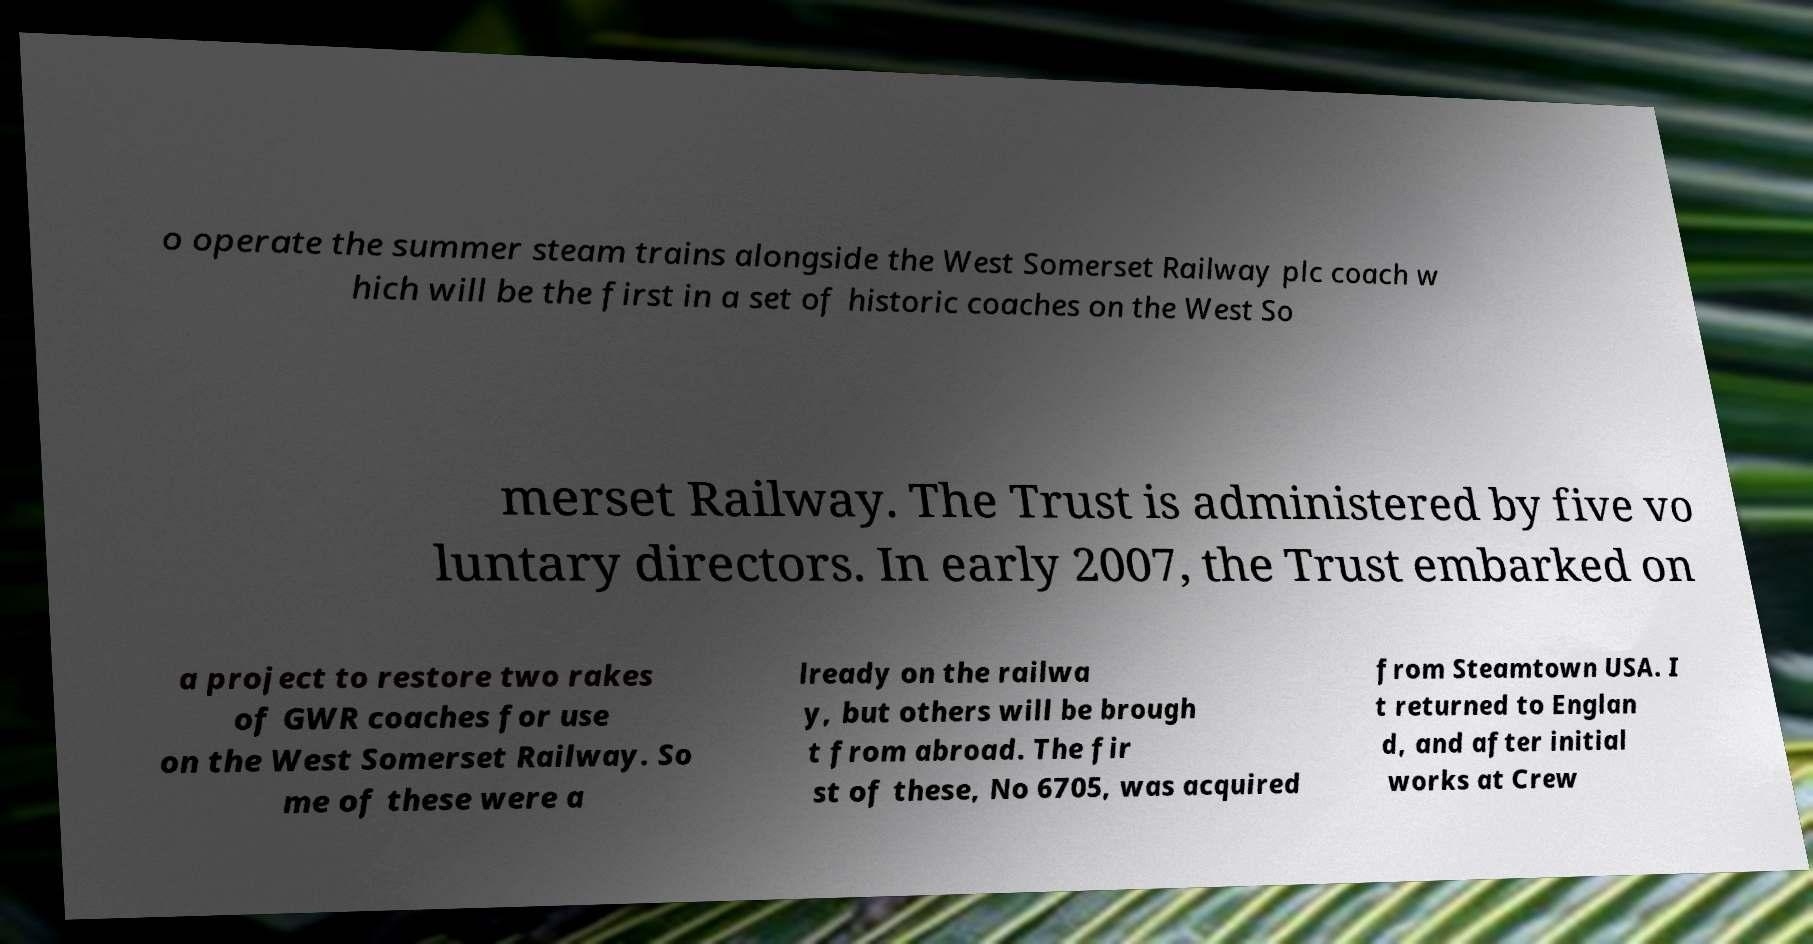Can you read and provide the text displayed in the image?This photo seems to have some interesting text. Can you extract and type it out for me? o operate the summer steam trains alongside the West Somerset Railway plc coach w hich will be the first in a set of historic coaches on the West So merset Railway. The Trust is administered by five vo luntary directors. In early 2007, the Trust embarked on a project to restore two rakes of GWR coaches for use on the West Somerset Railway. So me of these were a lready on the railwa y, but others will be brough t from abroad. The fir st of these, No 6705, was acquired from Steamtown USA. I t returned to Englan d, and after initial works at Crew 